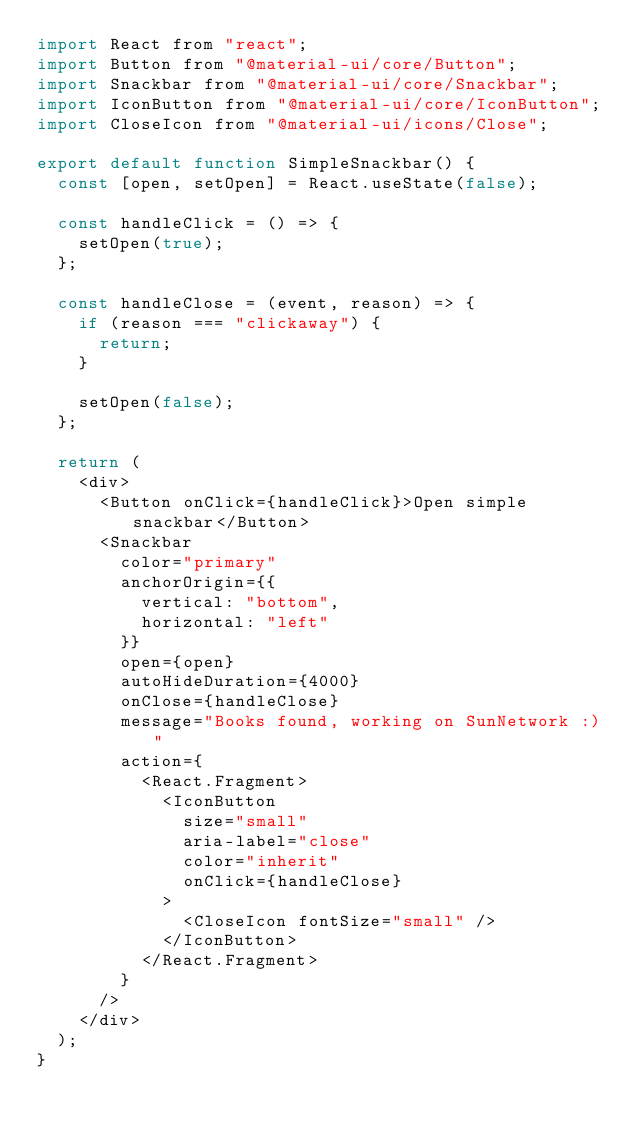Convert code to text. <code><loc_0><loc_0><loc_500><loc_500><_JavaScript_>import React from "react";
import Button from "@material-ui/core/Button";
import Snackbar from "@material-ui/core/Snackbar";
import IconButton from "@material-ui/core/IconButton";
import CloseIcon from "@material-ui/icons/Close";

export default function SimpleSnackbar() {
  const [open, setOpen] = React.useState(false);

  const handleClick = () => {
    setOpen(true);
  };

  const handleClose = (event, reason) => {
    if (reason === "clickaway") {
      return;
    }

    setOpen(false);
  };

  return (
    <div>
      <Button onClick={handleClick}>Open simple snackbar</Button>
      <Snackbar
        color="primary"
        anchorOrigin={{
          vertical: "bottom",
          horizontal: "left"
        }}
        open={open}
        autoHideDuration={4000}
        onClose={handleClose}
        message="Books found, working on SunNetwork :)"
        action={
          <React.Fragment>
            <IconButton
              size="small"
              aria-label="close"
              color="inherit"
              onClick={handleClose}
            >
              <CloseIcon fontSize="small" />
            </IconButton>
          </React.Fragment>
        }
      />
    </div>
  );
}
</code> 